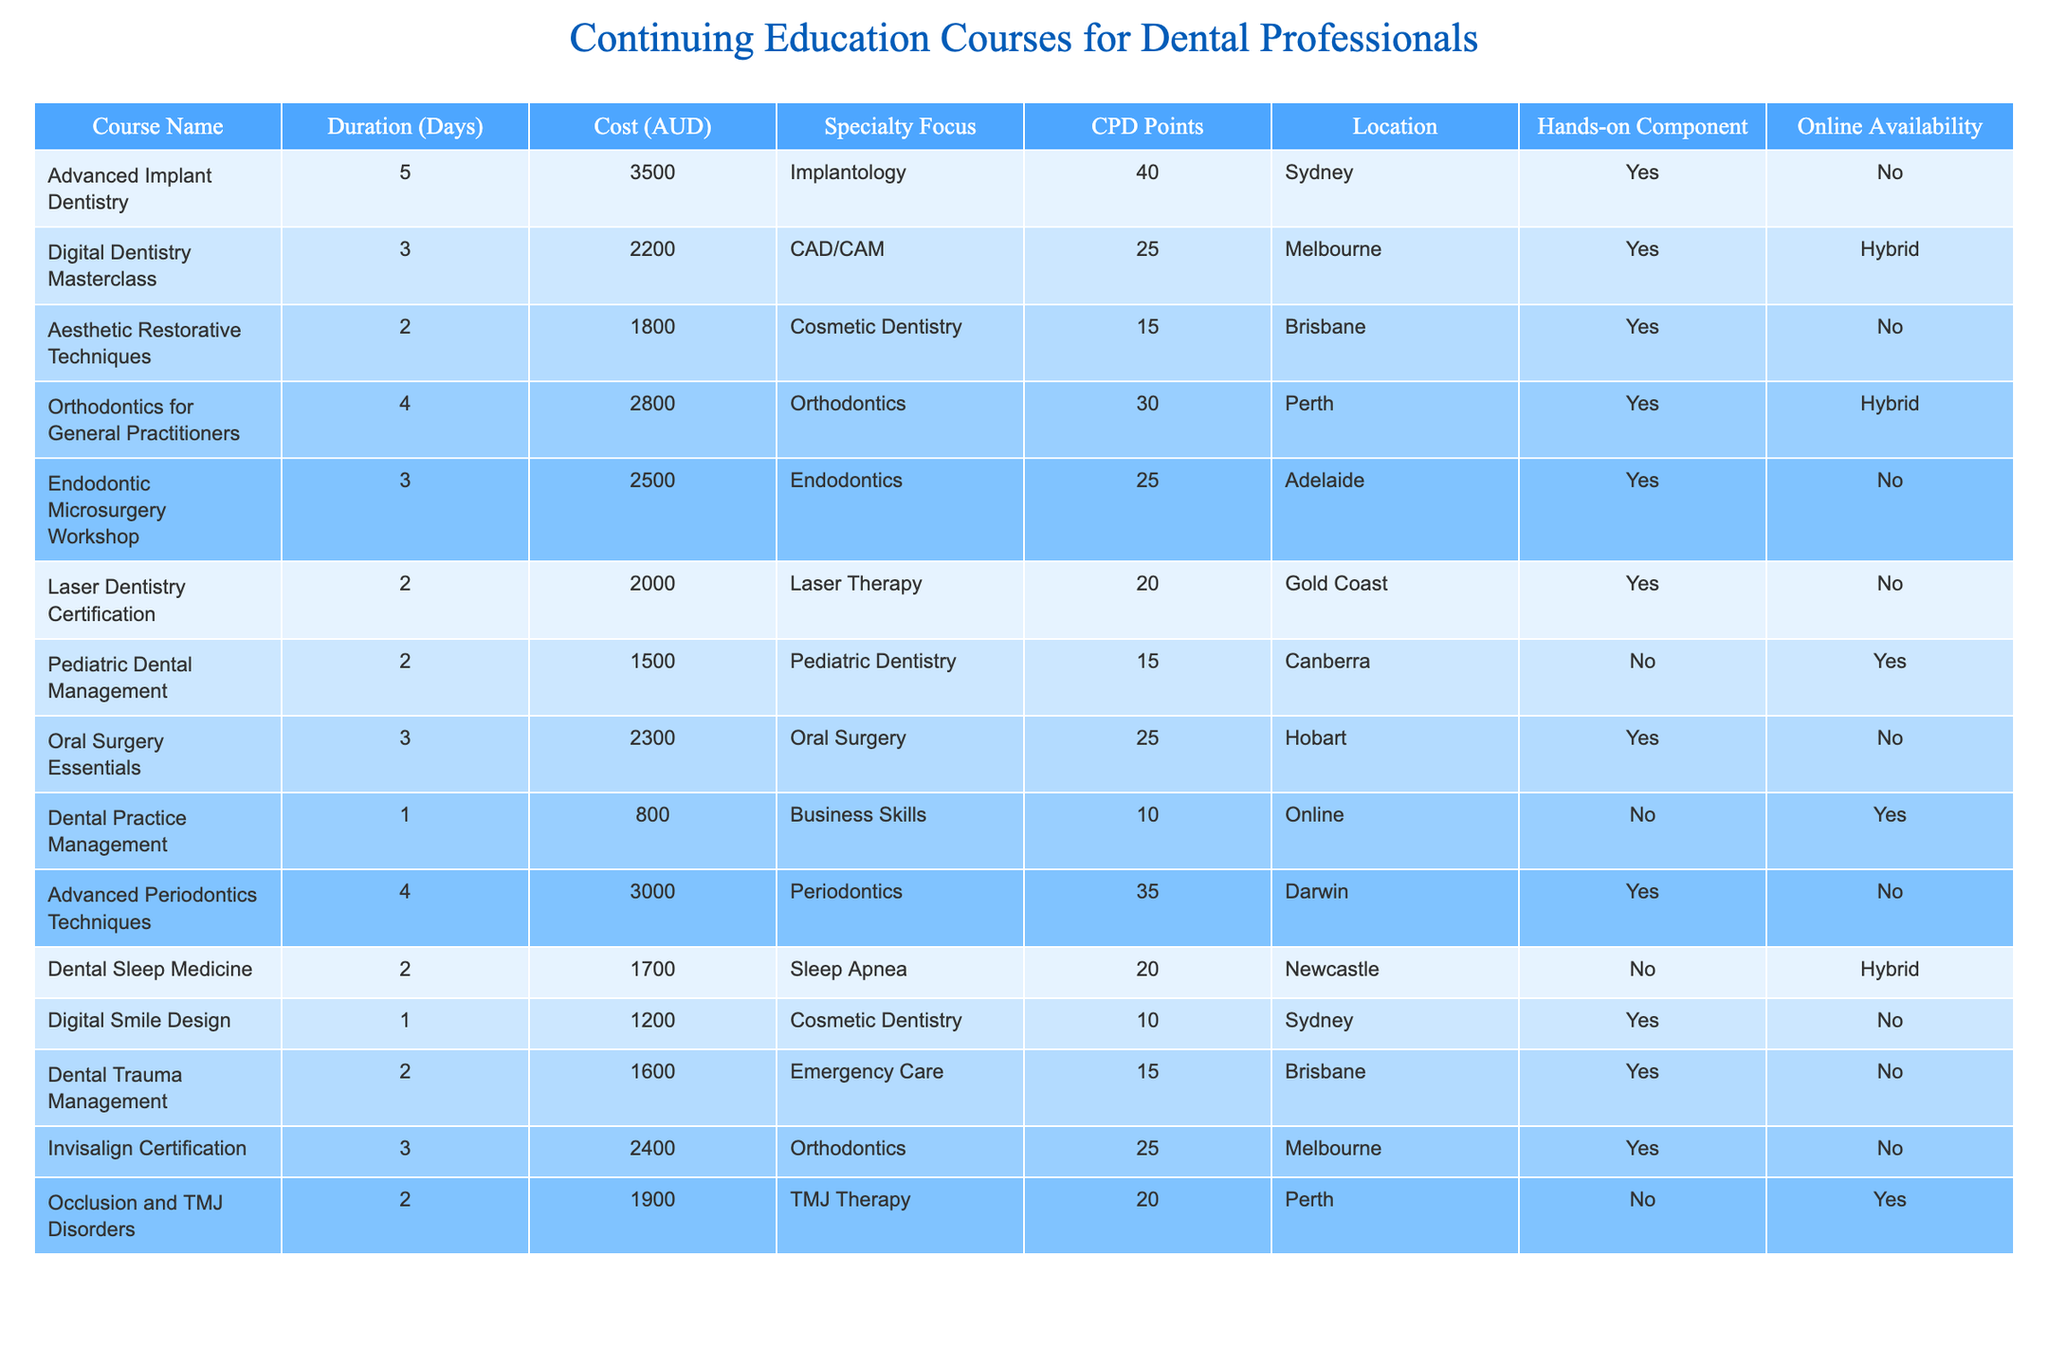What is the cost of the Advanced Implant Dentistry course? The table lists the cost for the Advanced Implant Dentistry course as 3500 AUD.
Answer: 3500 AUD Which course offers the most CPD points? The Advanced Implant Dentistry course provides the highest CPD points at 40, surpassing all other courses listed.
Answer: 40 points Is there an online available course focused on Pediatric Dentistry? The Pediatric Dental Management course has online availability as indicated in the table.
Answer: Yes What is the average duration of the courses that include a hands-on component? The courses with hands-on components are Advanced Implant Dentistry (5 days), Digital Dentistry Masterclass (3 days), Aesthetic Restorative Techniques (2 days), Orthodontics for General Practitioners (4 days), Endodontic Microsurgery Workshop (3 days), and Oral Surgery Essentials (3 days). The total duration is 5 + 3 + 2 + 4 + 3 + 3 = 20 days. With 6 courses, the average is 20/6 = approximately 3.33 days.
Answer: Approximately 3.33 days How many courses have a cost of less than 2000 AUD? Examining the table, the courses costing less than 2000 AUD are Pediatric Dental Management (1500 AUD), Laser Dentistry Certification (2000 AUD, not included), and Dental Trauma Management (1600 AUD). Thus, 2 courses meet this criterion.
Answer: 2 courses What is the total cost for the courses available in Melbourne? The courses available in Melbourne are the Digital Dentistry Masterclass (2200 AUD) and Invisalign Certification (2400 AUD), totaling 2200 + 2400 = 4600 AUD.
Answer: 4600 AUD Which course does not have a hands-on component and is focused on Business Skills? The table indicates that the Dental Practice Management course is the only one that focuses on Business Skills and does not have a hands-on component.
Answer: Dental Practice Management Are there any courses with a duration of 2 days that offer CPD points? The courses with a duration of 2 days are Aesthetic Restorative Techniques (15 points), Laser Dentistry Certification (20 points), Pediatric Dental Management (15 points), and Occlusion and TMJ Disorders (20 points). Therefore, there are 4 such courses offering CPD points.
Answer: Yes, 4 courses 